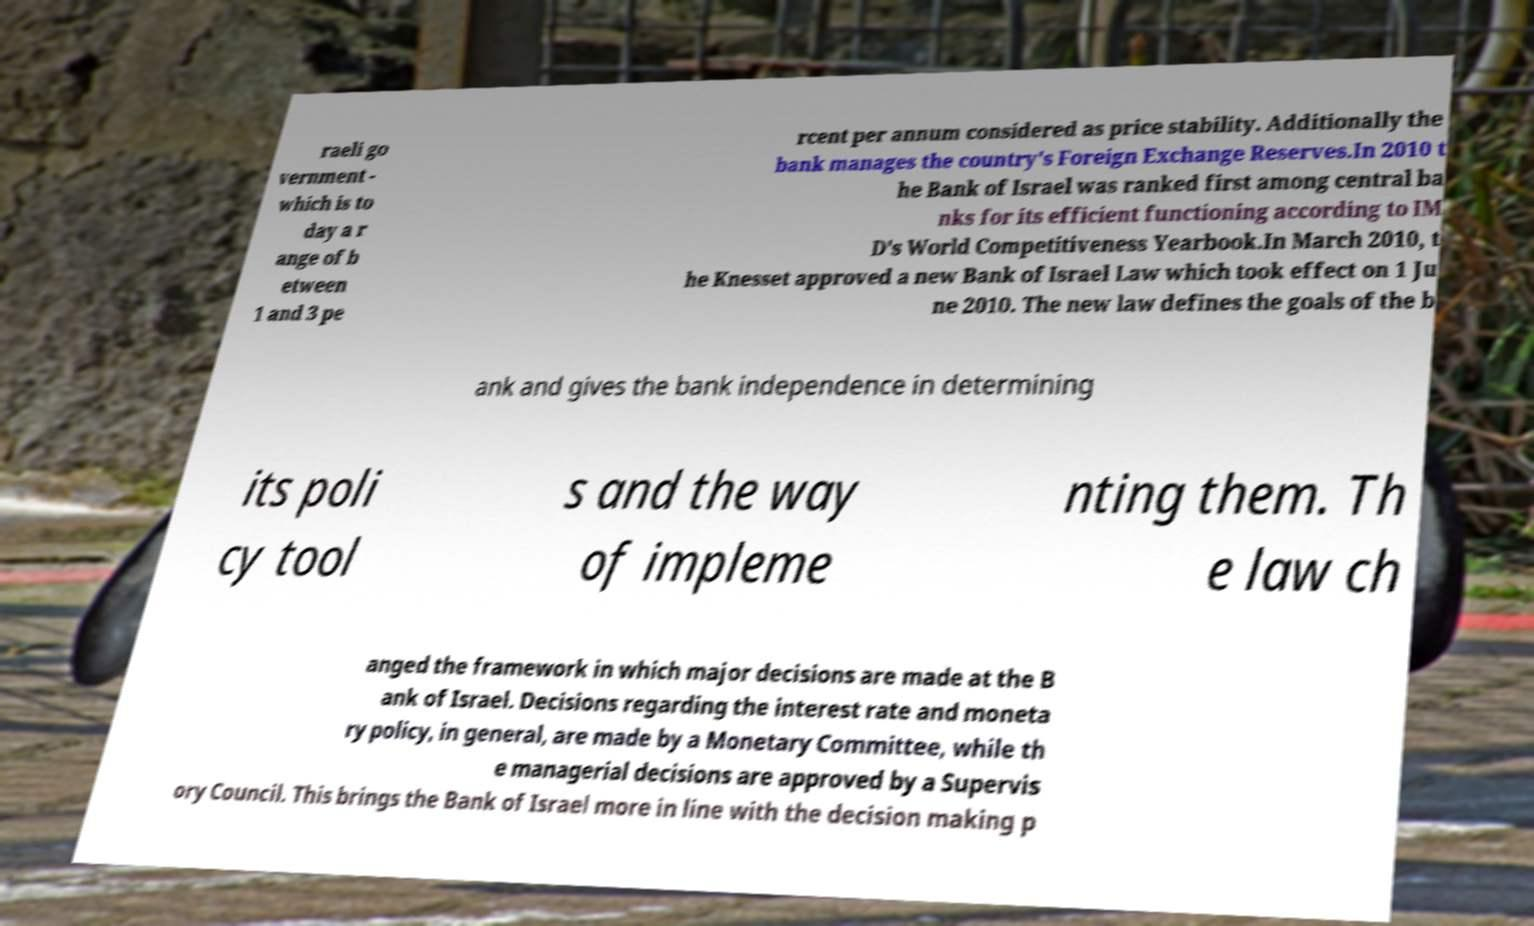For documentation purposes, I need the text within this image transcribed. Could you provide that? raeli go vernment - which is to day a r ange of b etween 1 and 3 pe rcent per annum considered as price stability. Additionally the bank manages the country's Foreign Exchange Reserves.In 2010 t he Bank of Israel was ranked first among central ba nks for its efficient functioning according to IM D's World Competitiveness Yearbook.In March 2010, t he Knesset approved a new Bank of Israel Law which took effect on 1 Ju ne 2010. The new law defines the goals of the b ank and gives the bank independence in determining its poli cy tool s and the way of impleme nting them. Th e law ch anged the framework in which major decisions are made at the B ank of Israel. Decisions regarding the interest rate and moneta ry policy, in general, are made by a Monetary Committee, while th e managerial decisions are approved by a Supervis ory Council. This brings the Bank of Israel more in line with the decision making p 